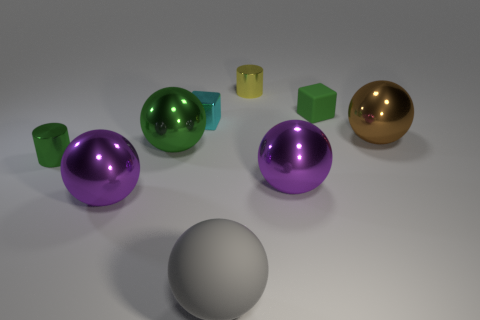What number of gray matte spheres are right of the green thing behind the big green shiny thing?
Offer a terse response. 0. Is the number of tiny metallic cylinders that are on the left side of the cyan shiny block greater than the number of things behind the tiny yellow thing?
Provide a succinct answer. Yes. What is the material of the tiny yellow object?
Ensure brevity in your answer.  Metal. Is there a block that has the same size as the gray ball?
Your answer should be very brief. No. There is a green thing that is the same size as the gray matte ball; what material is it?
Give a very brief answer. Metal. How many small yellow shiny spheres are there?
Your answer should be compact. 0. What size is the green metal thing that is to the right of the tiny green metal cylinder?
Provide a succinct answer. Large. Is the number of purple spheres that are right of the brown object the same as the number of cyan blocks?
Give a very brief answer. No. Is there another big rubber thing of the same shape as the brown thing?
Provide a short and direct response. Yes. The big object that is left of the small yellow metal object and right of the cyan shiny object has what shape?
Make the answer very short. Sphere. 